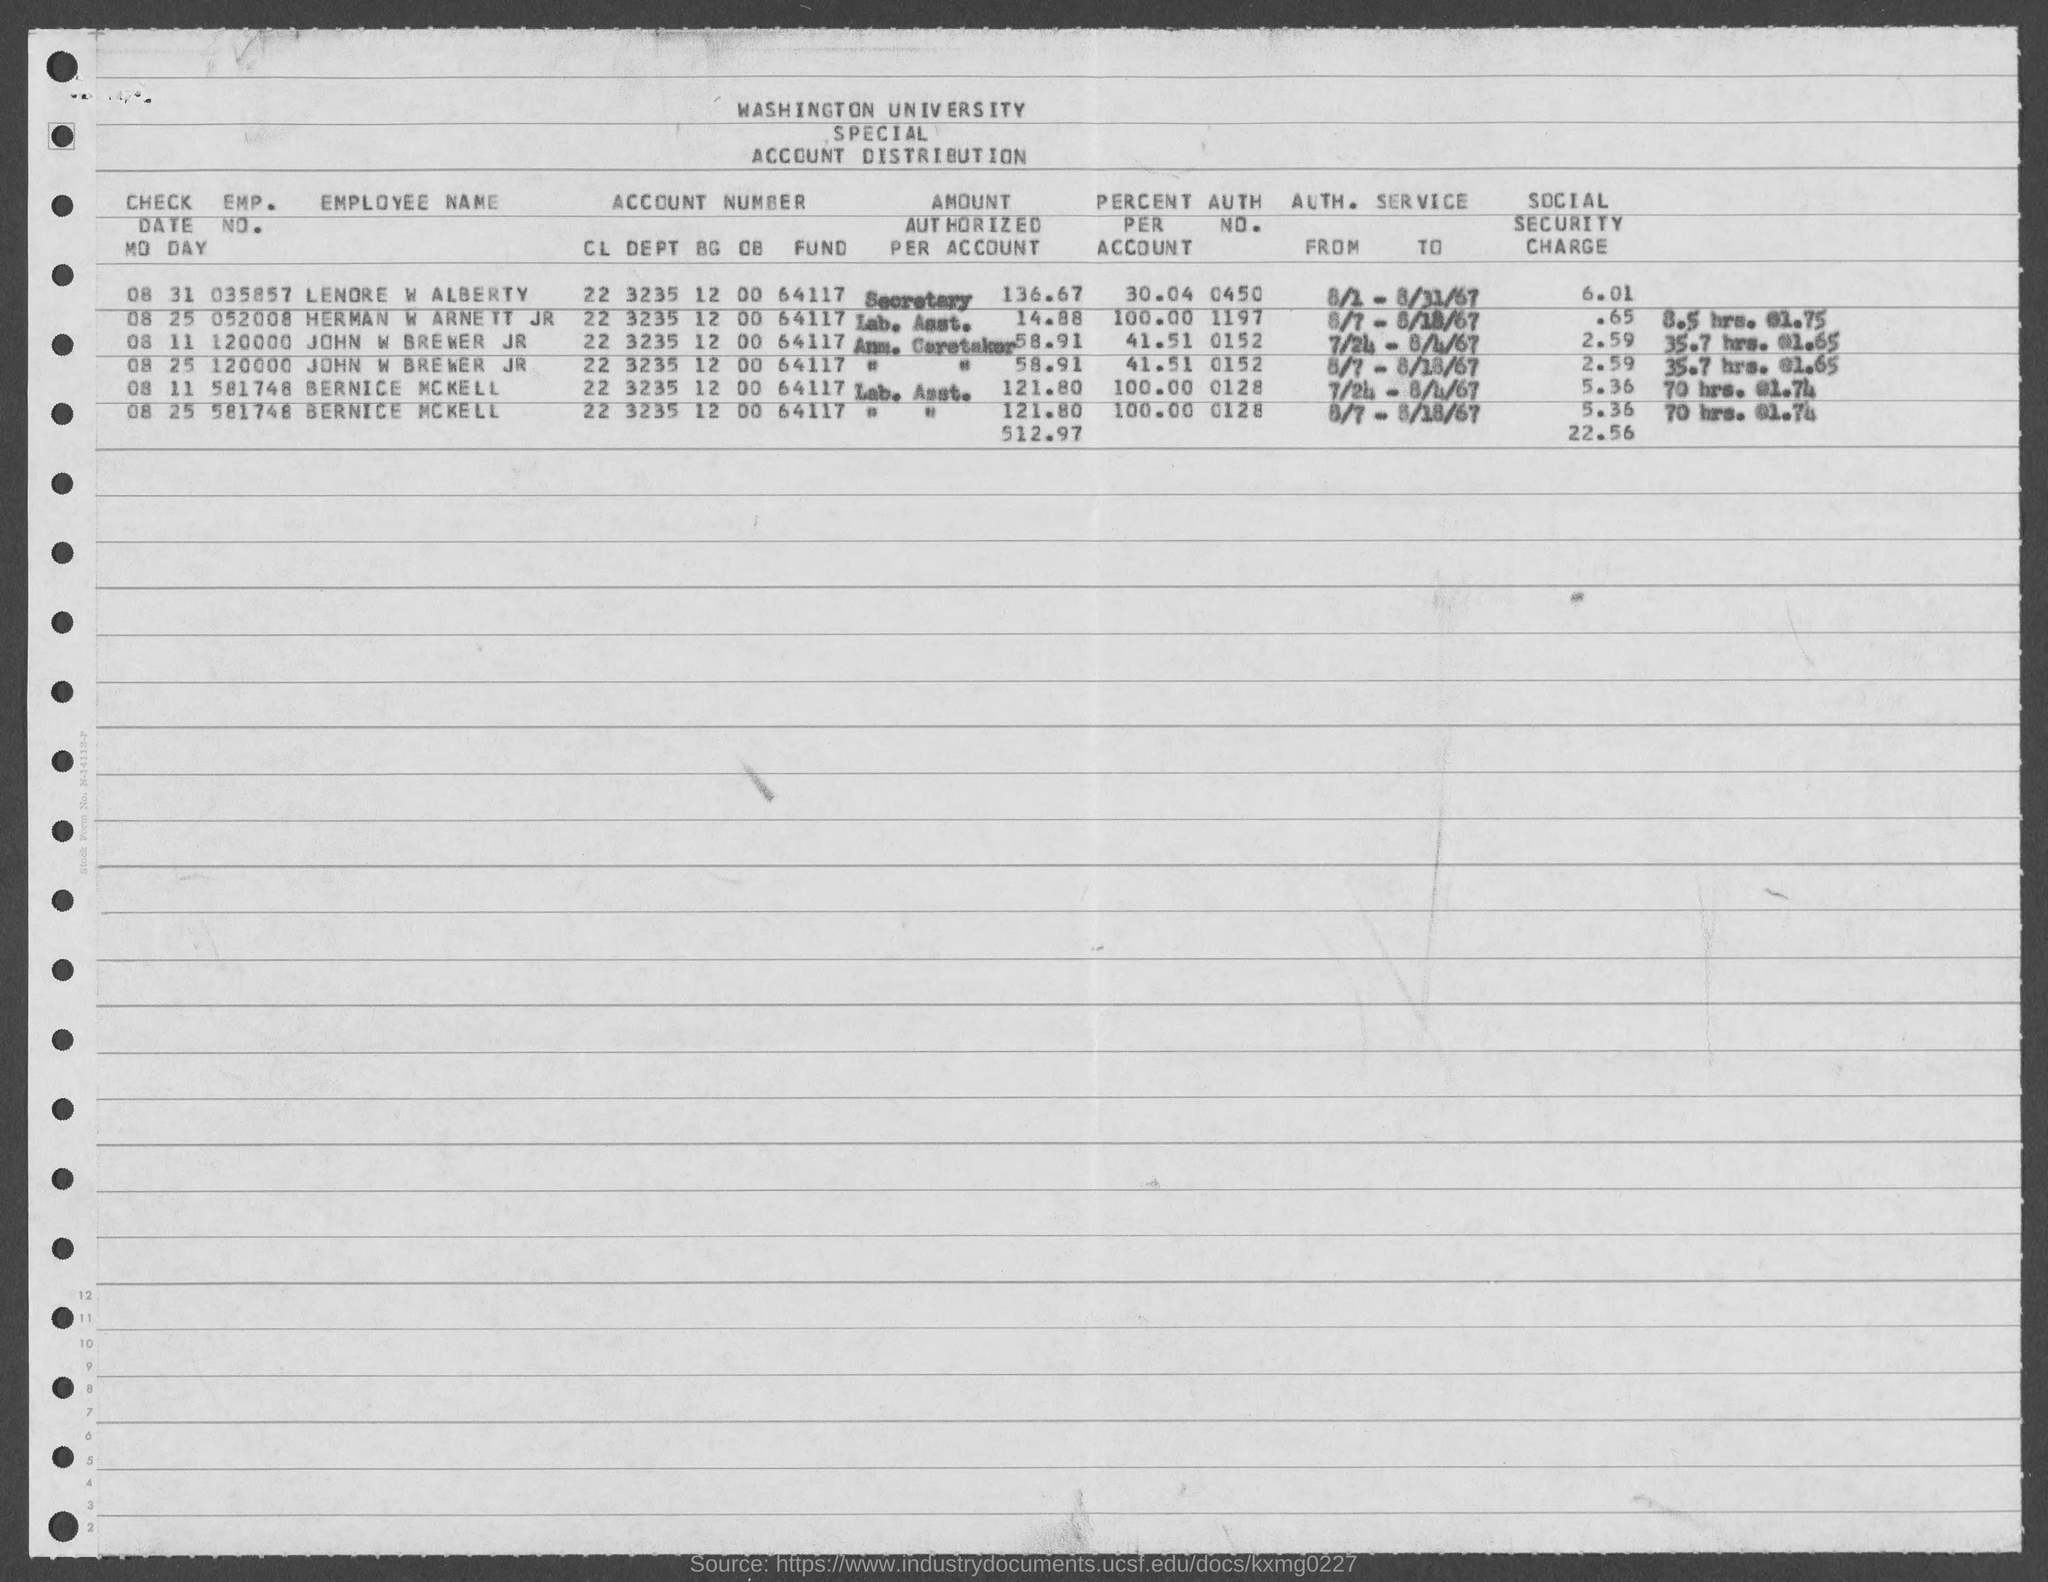What is the auth no. for john w brewer jr ?
Make the answer very short. 0152. What is the emp. no. for lenore w alaberty  mentioned in the given page ?
Provide a short and direct response. 035857. What is the emp. no. for herman w arnett jr ?
Provide a short and direct response. 052008. What is the emp. no. of john w brewer jr as mentioned in the given page ?
Keep it short and to the point. 120000. What is the emp. no. of bernice mckell as mentioned in the given form ?
Your answer should be compact. 581748. 